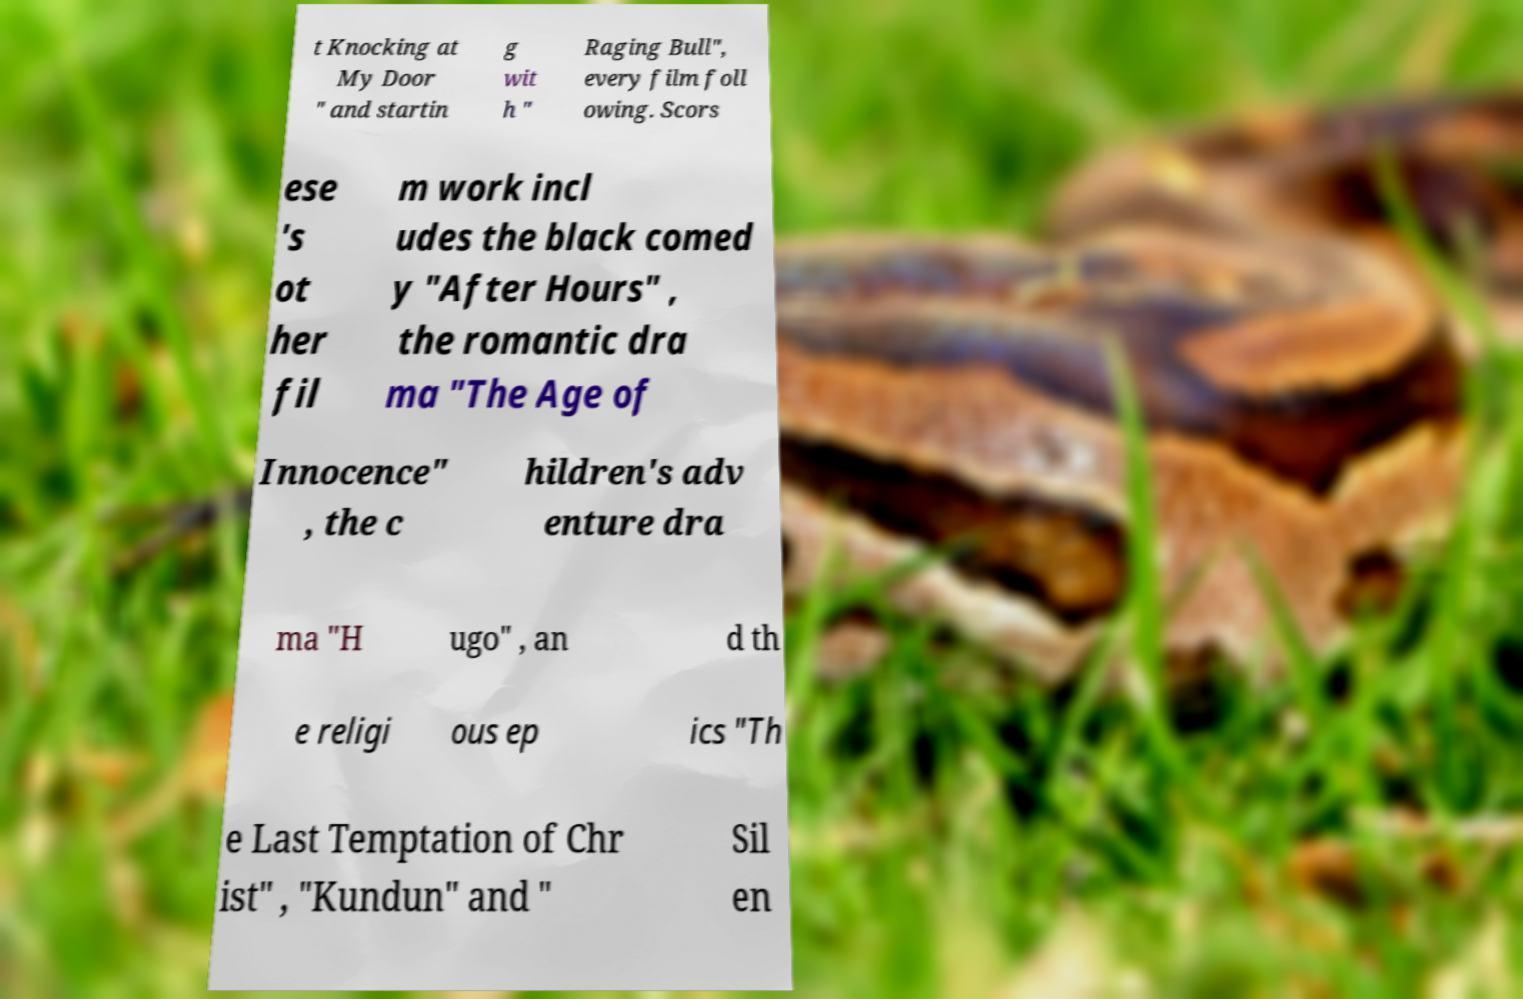Can you accurately transcribe the text from the provided image for me? t Knocking at My Door " and startin g wit h " Raging Bull", every film foll owing. Scors ese 's ot her fil m work incl udes the black comed y "After Hours" , the romantic dra ma "The Age of Innocence" , the c hildren's adv enture dra ma "H ugo" , an d th e religi ous ep ics "Th e Last Temptation of Chr ist" , "Kundun" and " Sil en 